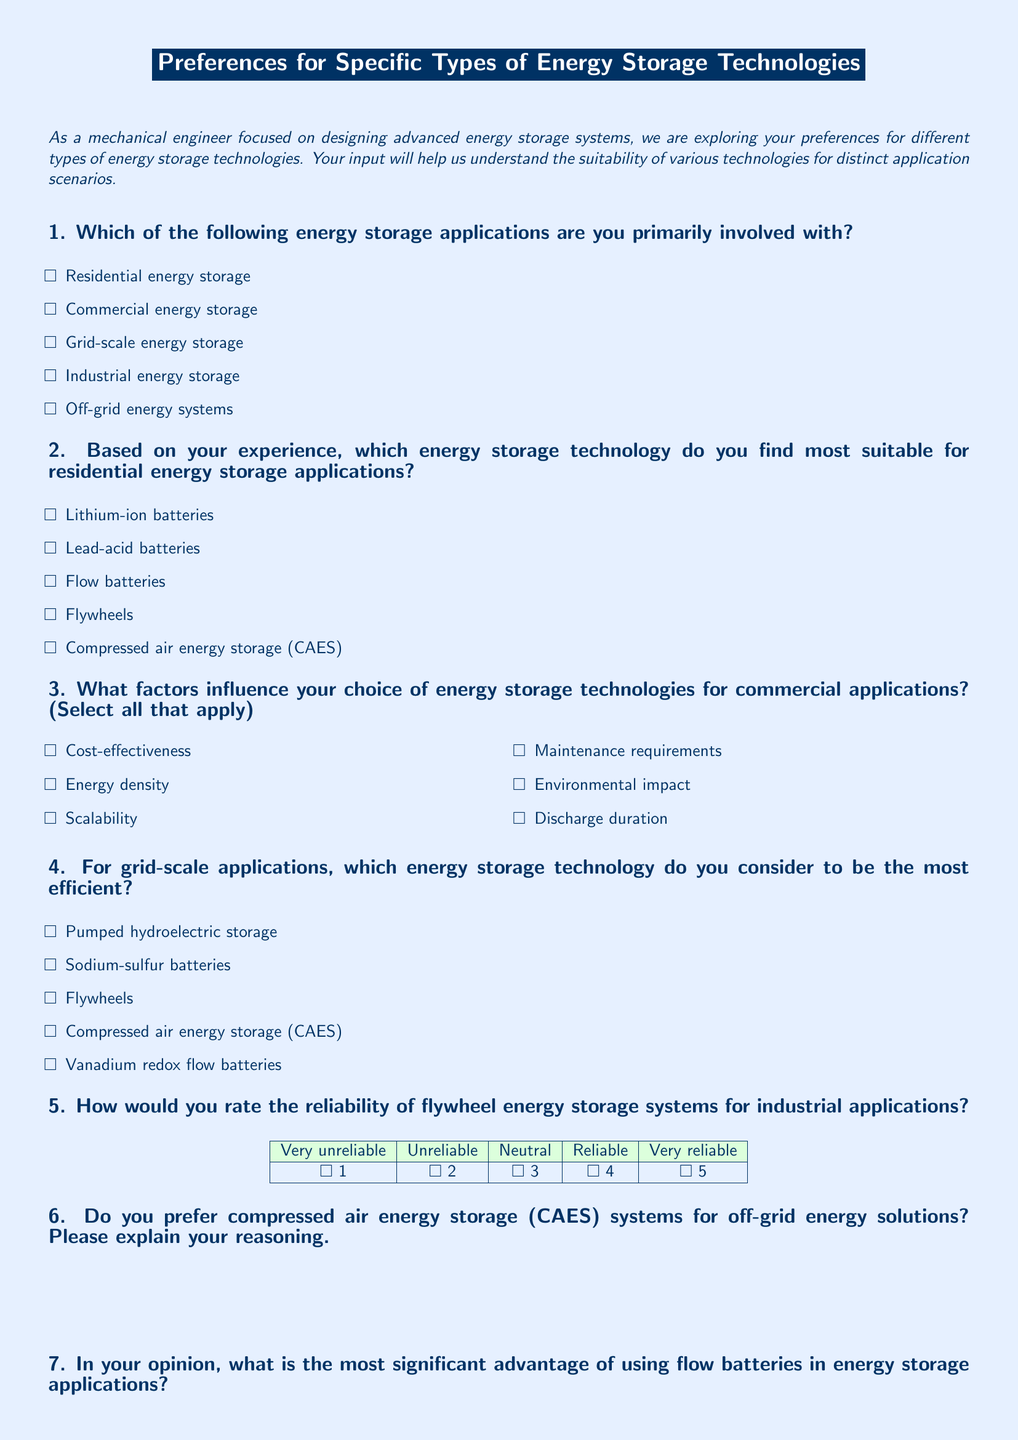What is the title of the document? The title is displayed prominently at the top of the document, indicating its focus on energy storage technologies.
Answer: Preferences for Specific Types of Energy Storage Technologies What is the first question in the survey? The first question asks about the primary involvement in energy storage applications, revealing the target audience of the survey.
Answer: Which of the following energy storage applications are you primarily involved with? How many energy storage technologies are listed for residential applications? The document presents a choice of five technologies specifically for residential energy storage.
Answer: 5 What are two factors influencing the choice of storage technologies for commercial applications? The document lists several factors, and selecting any two would provide insight into preferences in commercial technology choices.
Answer: Cost-effectiveness, Energy density What rating scale is used for flywheel reliability in industrial applications? The document includes a reliability rating scale ranging from very unreliable to very reliable, reflecting the survey's structure.
Answer: Very unreliable to very reliable What significant advantage of flow batteries is mentioned? The document includes a question seeking to identify a notable benefit of flow batteries, indicating their importance in energy storage.
Answer: Longer life span Does the survey ask for an explanation about CAES systems for off-grid solutions? The survey includes an open-ended question specifically requesting participants to explain their preferences regarding CAES for off-grid solutions.
Answer: Yes What is the purpose of the survey as described in the introduction? The introduction outlines the aim of the survey, focusing on understanding preferences for energy storage technologies.
Answer: To explore preferences for different types of energy storage technologies 